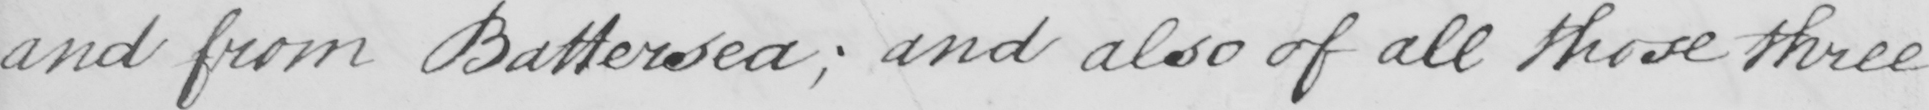What is written in this line of handwriting? and from Battersea ; and also of all those three 